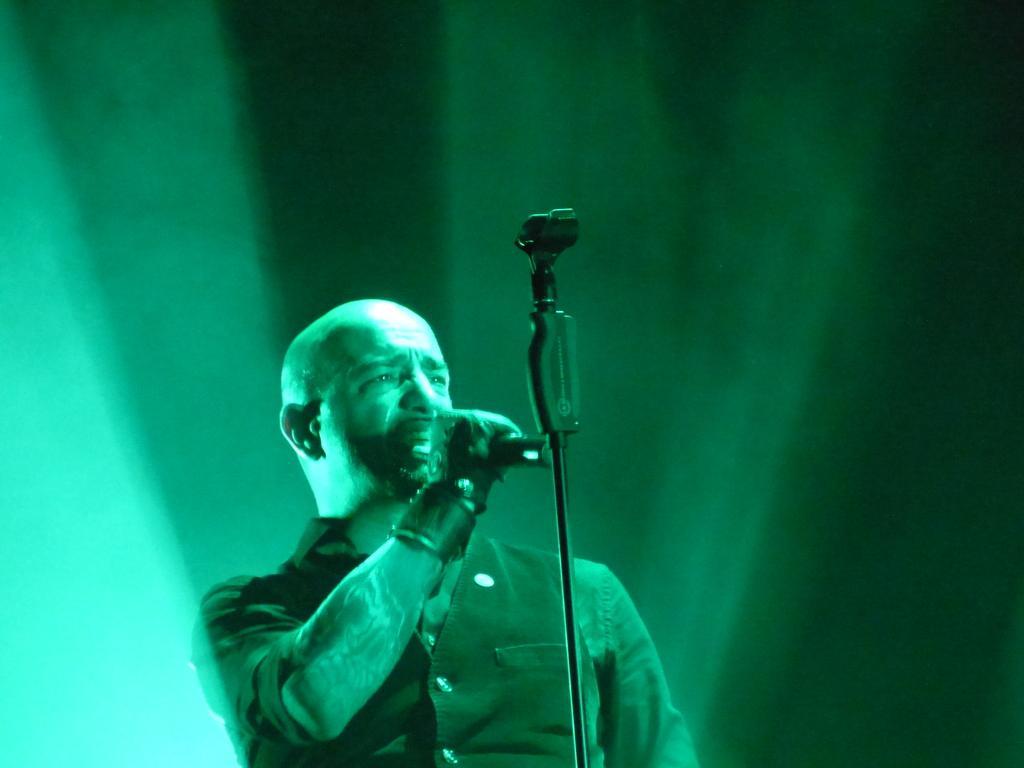Please provide a concise description of this image. In this image we can see a person is singing a song and holding a mike in his hand. 